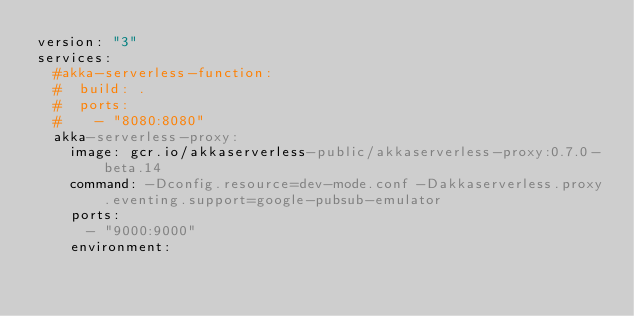Convert code to text. <code><loc_0><loc_0><loc_500><loc_500><_YAML_>version: "3"
services:
  #akka-serverless-function:
  #  build: .
  #  ports:
  #    - "8080:8080"
  akka-serverless-proxy:
    image: gcr.io/akkaserverless-public/akkaserverless-proxy:0.7.0-beta.14
    command: -Dconfig.resource=dev-mode.conf -Dakkaserverless.proxy.eventing.support=google-pubsub-emulator
    ports:
      - "9000:9000"
    environment:</code> 